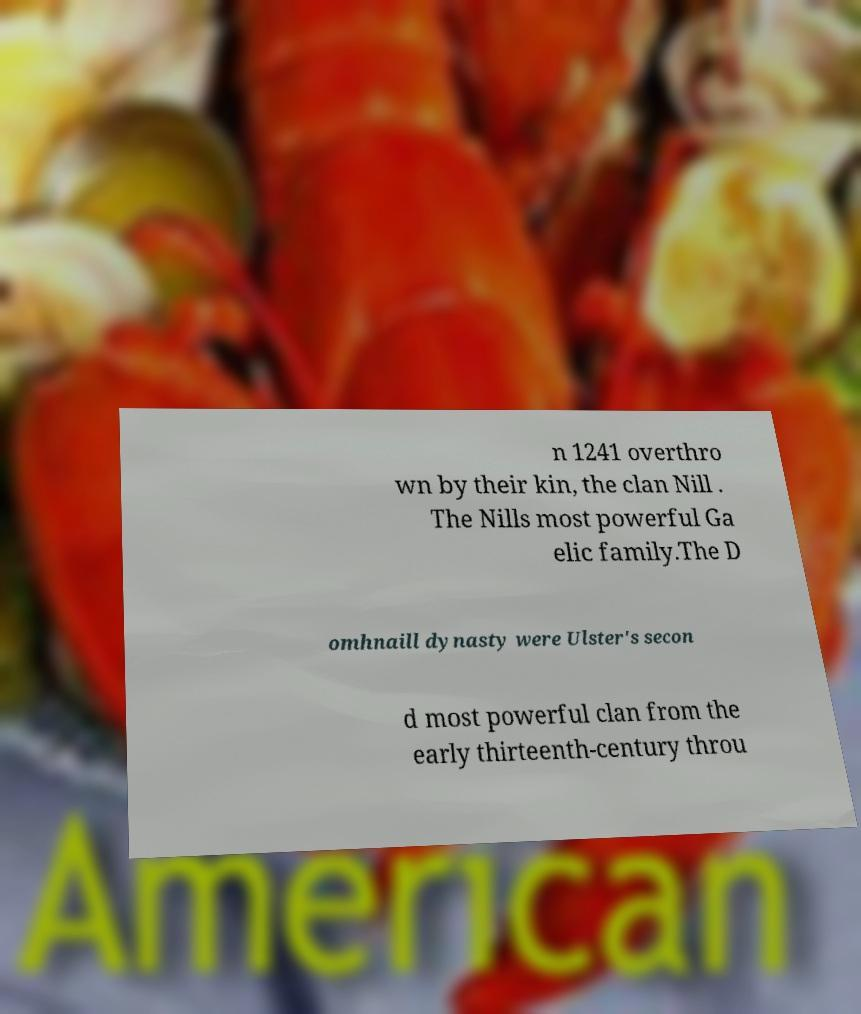Could you extract and type out the text from this image? n 1241 overthro wn by their kin, the clan Nill . The Nills most powerful Ga elic family.The D omhnaill dynasty were Ulster's secon d most powerful clan from the early thirteenth-century throu 